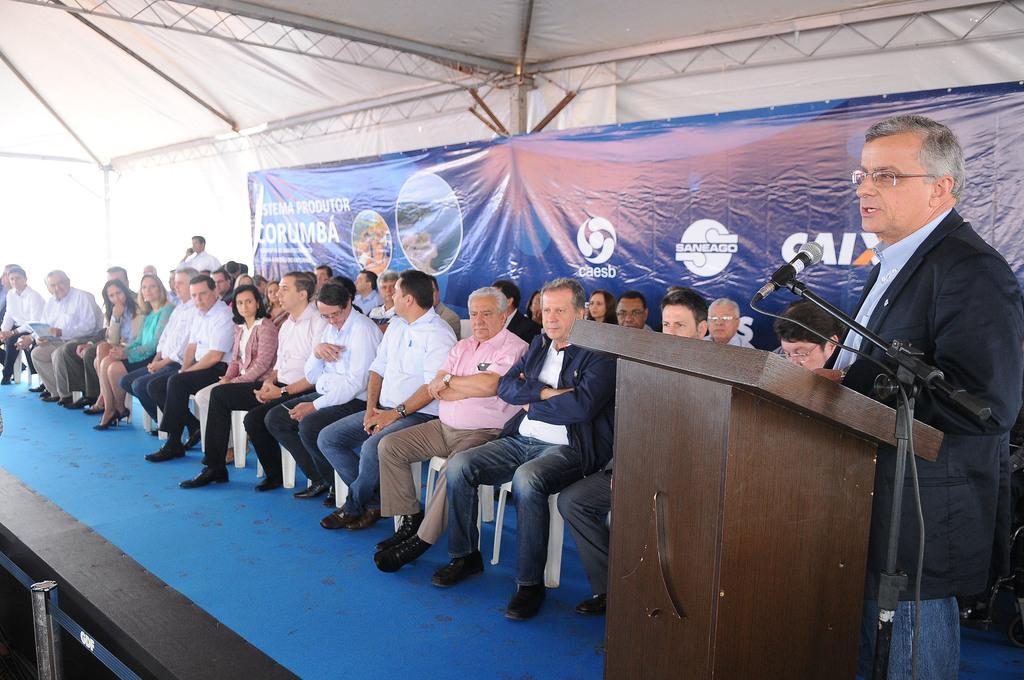Can you describe this image briefly? Here we can see few persons sitting on the chairs on the stage under a tent. On the right a man is standing at the podium and there is a mike to a stand. On the left at the bottom there is a pole. In the background we can see a banner and poles. 